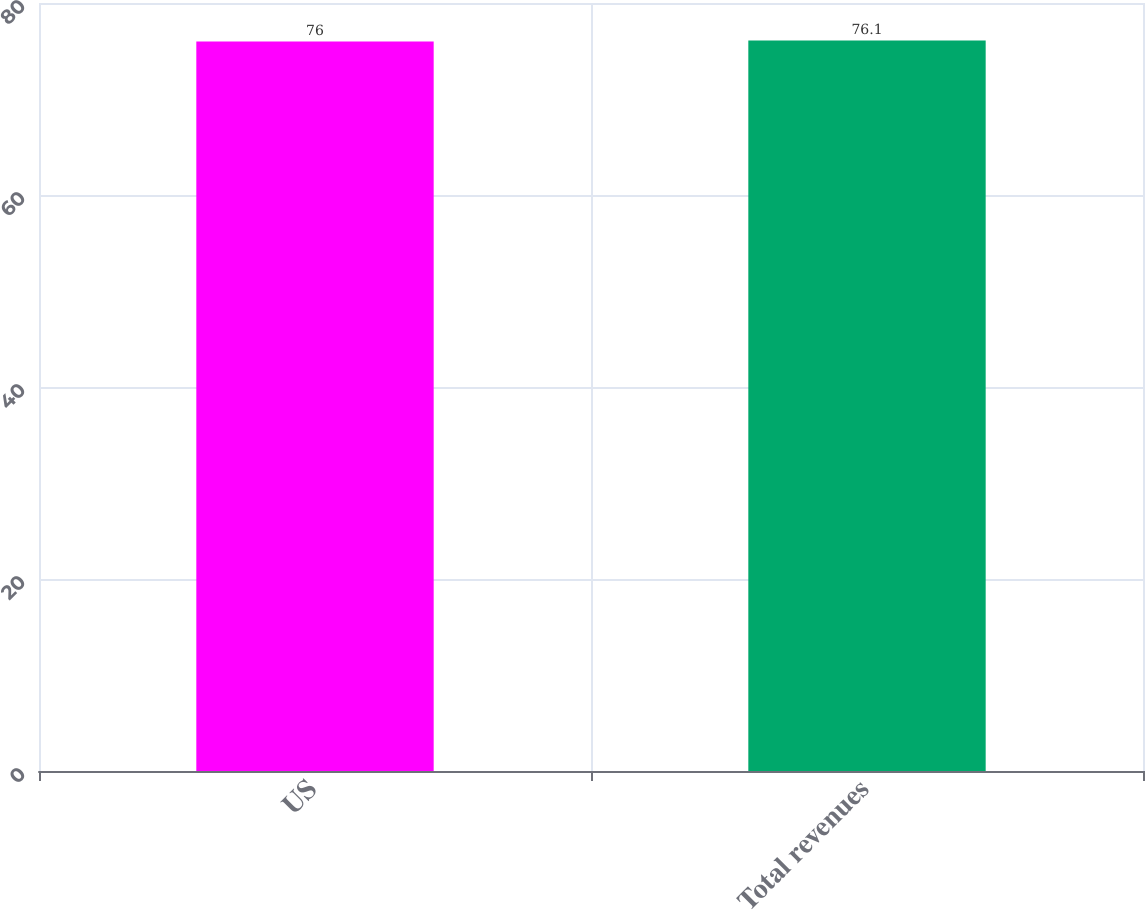Convert chart to OTSL. <chart><loc_0><loc_0><loc_500><loc_500><bar_chart><fcel>US<fcel>Total revenues<nl><fcel>76<fcel>76.1<nl></chart> 